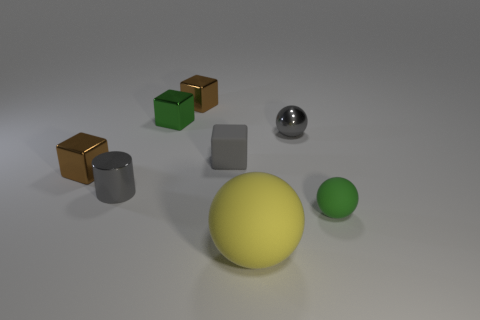Subtract all tiny gray spheres. How many spheres are left? 2 Add 1 large blue balls. How many objects exist? 9 Subtract all gray balls. How many balls are left? 2 Subtract 1 balls. How many balls are left? 2 Subtract all gray blocks. How many gray spheres are left? 1 Subtract 0 blue spheres. How many objects are left? 8 Subtract all cylinders. How many objects are left? 7 Subtract all blue cylinders. Subtract all red spheres. How many cylinders are left? 1 Subtract all big yellow balls. Subtract all gray cubes. How many objects are left? 6 Add 4 small brown things. How many small brown things are left? 6 